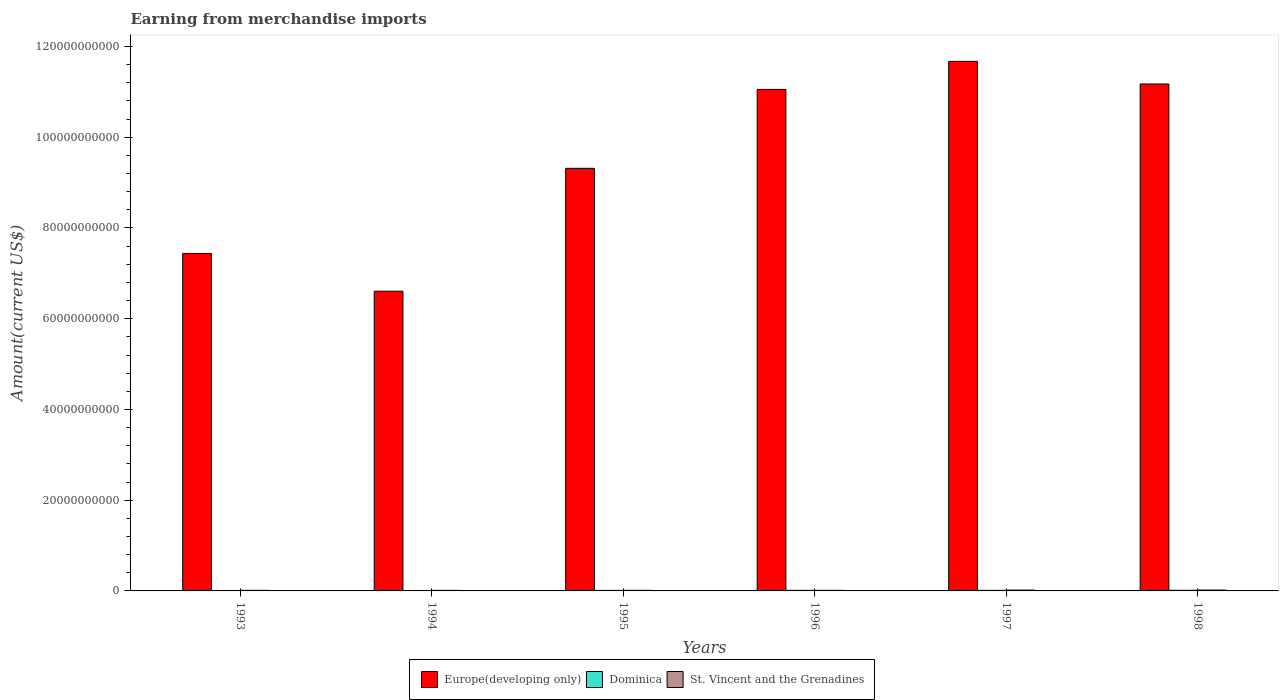Are the number of bars on each tick of the X-axis equal?
Keep it short and to the point. Yes. How many bars are there on the 6th tick from the left?
Ensure brevity in your answer.  3. How many bars are there on the 5th tick from the right?
Your answer should be compact. 3. What is the amount earned from merchandise imports in Dominica in 1996?
Offer a terse response. 1.29e+08. Across all years, what is the maximum amount earned from merchandise imports in St. Vincent and the Grenadines?
Ensure brevity in your answer.  1.93e+08. Across all years, what is the minimum amount earned from merchandise imports in St. Vincent and the Grenadines?
Your answer should be compact. 1.30e+08. What is the total amount earned from merchandise imports in Dominica in the graph?
Your answer should be very brief. 6.96e+08. What is the difference between the amount earned from merchandise imports in Europe(developing only) in 1996 and that in 1998?
Your answer should be compact. -1.19e+09. What is the difference between the amount earned from merchandise imports in Dominica in 1993 and the amount earned from merchandise imports in St. Vincent and the Grenadines in 1998?
Make the answer very short. -9.90e+07. What is the average amount earned from merchandise imports in Dominica per year?
Provide a short and direct response. 1.16e+08. In the year 1994, what is the difference between the amount earned from merchandise imports in Europe(developing only) and amount earned from merchandise imports in St. Vincent and the Grenadines?
Offer a very short reply. 6.59e+1. What is the ratio of the amount earned from merchandise imports in Europe(developing only) in 1994 to that in 1996?
Make the answer very short. 0.6. Is the amount earned from merchandise imports in Dominica in 1995 less than that in 1998?
Your response must be concise. Yes. What is the difference between the highest and the lowest amount earned from merchandise imports in Dominica?
Offer a very short reply. 4.20e+07. In how many years, is the amount earned from merchandise imports in Europe(developing only) greater than the average amount earned from merchandise imports in Europe(developing only) taken over all years?
Give a very brief answer. 3. What does the 1st bar from the left in 1998 represents?
Provide a succinct answer. Europe(developing only). What does the 2nd bar from the right in 1997 represents?
Keep it short and to the point. Dominica. How many bars are there?
Give a very brief answer. 18. What is the difference between two consecutive major ticks on the Y-axis?
Make the answer very short. 2.00e+1. Are the values on the major ticks of Y-axis written in scientific E-notation?
Keep it short and to the point. No. Does the graph contain any zero values?
Ensure brevity in your answer.  No. How many legend labels are there?
Provide a succinct answer. 3. How are the legend labels stacked?
Your response must be concise. Horizontal. What is the title of the graph?
Give a very brief answer. Earning from merchandise imports. What is the label or title of the Y-axis?
Your answer should be very brief. Amount(current US$). What is the Amount(current US$) of Europe(developing only) in 1993?
Provide a short and direct response. 7.44e+1. What is the Amount(current US$) in Dominica in 1993?
Your answer should be compact. 9.40e+07. What is the Amount(current US$) in St. Vincent and the Grenadines in 1993?
Offer a very short reply. 1.34e+08. What is the Amount(current US$) of Europe(developing only) in 1994?
Provide a succinct answer. 6.61e+1. What is the Amount(current US$) of Dominica in 1994?
Your answer should be compact. 9.60e+07. What is the Amount(current US$) of St. Vincent and the Grenadines in 1994?
Offer a very short reply. 1.30e+08. What is the Amount(current US$) in Europe(developing only) in 1995?
Ensure brevity in your answer.  9.31e+1. What is the Amount(current US$) of Dominica in 1995?
Make the answer very short. 1.17e+08. What is the Amount(current US$) of St. Vincent and the Grenadines in 1995?
Your response must be concise. 1.35e+08. What is the Amount(current US$) of Europe(developing only) in 1996?
Make the answer very short. 1.11e+11. What is the Amount(current US$) of Dominica in 1996?
Give a very brief answer. 1.29e+08. What is the Amount(current US$) of St. Vincent and the Grenadines in 1996?
Your answer should be very brief. 1.31e+08. What is the Amount(current US$) in Europe(developing only) in 1997?
Make the answer very short. 1.17e+11. What is the Amount(current US$) of Dominica in 1997?
Your answer should be very brief. 1.24e+08. What is the Amount(current US$) in St. Vincent and the Grenadines in 1997?
Ensure brevity in your answer.  1.88e+08. What is the Amount(current US$) in Europe(developing only) in 1998?
Give a very brief answer. 1.12e+11. What is the Amount(current US$) of Dominica in 1998?
Make the answer very short. 1.36e+08. What is the Amount(current US$) in St. Vincent and the Grenadines in 1998?
Provide a short and direct response. 1.93e+08. Across all years, what is the maximum Amount(current US$) of Europe(developing only)?
Offer a very short reply. 1.17e+11. Across all years, what is the maximum Amount(current US$) of Dominica?
Offer a very short reply. 1.36e+08. Across all years, what is the maximum Amount(current US$) of St. Vincent and the Grenadines?
Provide a short and direct response. 1.93e+08. Across all years, what is the minimum Amount(current US$) of Europe(developing only)?
Offer a very short reply. 6.61e+1. Across all years, what is the minimum Amount(current US$) in Dominica?
Make the answer very short. 9.40e+07. Across all years, what is the minimum Amount(current US$) of St. Vincent and the Grenadines?
Ensure brevity in your answer.  1.30e+08. What is the total Amount(current US$) in Europe(developing only) in the graph?
Your answer should be compact. 5.73e+11. What is the total Amount(current US$) in Dominica in the graph?
Offer a very short reply. 6.96e+08. What is the total Amount(current US$) in St. Vincent and the Grenadines in the graph?
Provide a short and direct response. 9.11e+08. What is the difference between the Amount(current US$) of Europe(developing only) in 1993 and that in 1994?
Make the answer very short. 8.33e+09. What is the difference between the Amount(current US$) in Dominica in 1993 and that in 1994?
Keep it short and to the point. -2.00e+06. What is the difference between the Amount(current US$) of St. Vincent and the Grenadines in 1993 and that in 1994?
Offer a very short reply. 4.00e+06. What is the difference between the Amount(current US$) in Europe(developing only) in 1993 and that in 1995?
Your answer should be compact. -1.88e+1. What is the difference between the Amount(current US$) in Dominica in 1993 and that in 1995?
Give a very brief answer. -2.30e+07. What is the difference between the Amount(current US$) in St. Vincent and the Grenadines in 1993 and that in 1995?
Offer a very short reply. -1.00e+06. What is the difference between the Amount(current US$) of Europe(developing only) in 1993 and that in 1996?
Keep it short and to the point. -3.62e+1. What is the difference between the Amount(current US$) of Dominica in 1993 and that in 1996?
Your response must be concise. -3.50e+07. What is the difference between the Amount(current US$) of Europe(developing only) in 1993 and that in 1997?
Give a very brief answer. -4.23e+1. What is the difference between the Amount(current US$) in Dominica in 1993 and that in 1997?
Provide a succinct answer. -3.00e+07. What is the difference between the Amount(current US$) of St. Vincent and the Grenadines in 1993 and that in 1997?
Your answer should be very brief. -5.40e+07. What is the difference between the Amount(current US$) in Europe(developing only) in 1993 and that in 1998?
Keep it short and to the point. -3.74e+1. What is the difference between the Amount(current US$) of Dominica in 1993 and that in 1998?
Provide a succinct answer. -4.20e+07. What is the difference between the Amount(current US$) in St. Vincent and the Grenadines in 1993 and that in 1998?
Give a very brief answer. -5.90e+07. What is the difference between the Amount(current US$) of Europe(developing only) in 1994 and that in 1995?
Make the answer very short. -2.71e+1. What is the difference between the Amount(current US$) in Dominica in 1994 and that in 1995?
Offer a terse response. -2.10e+07. What is the difference between the Amount(current US$) of St. Vincent and the Grenadines in 1994 and that in 1995?
Provide a short and direct response. -5.00e+06. What is the difference between the Amount(current US$) of Europe(developing only) in 1994 and that in 1996?
Offer a terse response. -4.45e+1. What is the difference between the Amount(current US$) in Dominica in 1994 and that in 1996?
Offer a terse response. -3.30e+07. What is the difference between the Amount(current US$) of St. Vincent and the Grenadines in 1994 and that in 1996?
Provide a succinct answer. -1.00e+06. What is the difference between the Amount(current US$) in Europe(developing only) in 1994 and that in 1997?
Your response must be concise. -5.07e+1. What is the difference between the Amount(current US$) in Dominica in 1994 and that in 1997?
Offer a very short reply. -2.80e+07. What is the difference between the Amount(current US$) in St. Vincent and the Grenadines in 1994 and that in 1997?
Offer a very short reply. -5.80e+07. What is the difference between the Amount(current US$) in Europe(developing only) in 1994 and that in 1998?
Give a very brief answer. -4.57e+1. What is the difference between the Amount(current US$) of Dominica in 1994 and that in 1998?
Make the answer very short. -4.00e+07. What is the difference between the Amount(current US$) in St. Vincent and the Grenadines in 1994 and that in 1998?
Your answer should be compact. -6.30e+07. What is the difference between the Amount(current US$) of Europe(developing only) in 1995 and that in 1996?
Your answer should be compact. -1.74e+1. What is the difference between the Amount(current US$) of Dominica in 1995 and that in 1996?
Your answer should be compact. -1.20e+07. What is the difference between the Amount(current US$) of Europe(developing only) in 1995 and that in 1997?
Provide a succinct answer. -2.36e+1. What is the difference between the Amount(current US$) of Dominica in 1995 and that in 1997?
Your answer should be very brief. -7.00e+06. What is the difference between the Amount(current US$) of St. Vincent and the Grenadines in 1995 and that in 1997?
Your response must be concise. -5.30e+07. What is the difference between the Amount(current US$) in Europe(developing only) in 1995 and that in 1998?
Offer a very short reply. -1.86e+1. What is the difference between the Amount(current US$) of Dominica in 1995 and that in 1998?
Your response must be concise. -1.90e+07. What is the difference between the Amount(current US$) of St. Vincent and the Grenadines in 1995 and that in 1998?
Offer a very short reply. -5.80e+07. What is the difference between the Amount(current US$) of Europe(developing only) in 1996 and that in 1997?
Ensure brevity in your answer.  -6.19e+09. What is the difference between the Amount(current US$) of St. Vincent and the Grenadines in 1996 and that in 1997?
Your answer should be compact. -5.70e+07. What is the difference between the Amount(current US$) in Europe(developing only) in 1996 and that in 1998?
Offer a very short reply. -1.19e+09. What is the difference between the Amount(current US$) of Dominica in 1996 and that in 1998?
Provide a short and direct response. -7.00e+06. What is the difference between the Amount(current US$) of St. Vincent and the Grenadines in 1996 and that in 1998?
Your response must be concise. -6.20e+07. What is the difference between the Amount(current US$) in Europe(developing only) in 1997 and that in 1998?
Provide a short and direct response. 4.99e+09. What is the difference between the Amount(current US$) in Dominica in 1997 and that in 1998?
Your answer should be very brief. -1.20e+07. What is the difference between the Amount(current US$) in St. Vincent and the Grenadines in 1997 and that in 1998?
Give a very brief answer. -5.00e+06. What is the difference between the Amount(current US$) of Europe(developing only) in 1993 and the Amount(current US$) of Dominica in 1994?
Ensure brevity in your answer.  7.43e+1. What is the difference between the Amount(current US$) in Europe(developing only) in 1993 and the Amount(current US$) in St. Vincent and the Grenadines in 1994?
Your answer should be very brief. 7.43e+1. What is the difference between the Amount(current US$) of Dominica in 1993 and the Amount(current US$) of St. Vincent and the Grenadines in 1994?
Keep it short and to the point. -3.60e+07. What is the difference between the Amount(current US$) of Europe(developing only) in 1993 and the Amount(current US$) of Dominica in 1995?
Offer a very short reply. 7.43e+1. What is the difference between the Amount(current US$) in Europe(developing only) in 1993 and the Amount(current US$) in St. Vincent and the Grenadines in 1995?
Offer a terse response. 7.42e+1. What is the difference between the Amount(current US$) in Dominica in 1993 and the Amount(current US$) in St. Vincent and the Grenadines in 1995?
Keep it short and to the point. -4.10e+07. What is the difference between the Amount(current US$) of Europe(developing only) in 1993 and the Amount(current US$) of Dominica in 1996?
Offer a very short reply. 7.43e+1. What is the difference between the Amount(current US$) of Europe(developing only) in 1993 and the Amount(current US$) of St. Vincent and the Grenadines in 1996?
Make the answer very short. 7.43e+1. What is the difference between the Amount(current US$) of Dominica in 1993 and the Amount(current US$) of St. Vincent and the Grenadines in 1996?
Provide a succinct answer. -3.70e+07. What is the difference between the Amount(current US$) of Europe(developing only) in 1993 and the Amount(current US$) of Dominica in 1997?
Provide a short and direct response. 7.43e+1. What is the difference between the Amount(current US$) in Europe(developing only) in 1993 and the Amount(current US$) in St. Vincent and the Grenadines in 1997?
Provide a succinct answer. 7.42e+1. What is the difference between the Amount(current US$) of Dominica in 1993 and the Amount(current US$) of St. Vincent and the Grenadines in 1997?
Make the answer very short. -9.40e+07. What is the difference between the Amount(current US$) in Europe(developing only) in 1993 and the Amount(current US$) in Dominica in 1998?
Give a very brief answer. 7.42e+1. What is the difference between the Amount(current US$) in Europe(developing only) in 1993 and the Amount(current US$) in St. Vincent and the Grenadines in 1998?
Your answer should be compact. 7.42e+1. What is the difference between the Amount(current US$) in Dominica in 1993 and the Amount(current US$) in St. Vincent and the Grenadines in 1998?
Provide a succinct answer. -9.90e+07. What is the difference between the Amount(current US$) of Europe(developing only) in 1994 and the Amount(current US$) of Dominica in 1995?
Your answer should be very brief. 6.59e+1. What is the difference between the Amount(current US$) in Europe(developing only) in 1994 and the Amount(current US$) in St. Vincent and the Grenadines in 1995?
Offer a terse response. 6.59e+1. What is the difference between the Amount(current US$) in Dominica in 1994 and the Amount(current US$) in St. Vincent and the Grenadines in 1995?
Offer a very short reply. -3.90e+07. What is the difference between the Amount(current US$) in Europe(developing only) in 1994 and the Amount(current US$) in Dominica in 1996?
Give a very brief answer. 6.59e+1. What is the difference between the Amount(current US$) of Europe(developing only) in 1994 and the Amount(current US$) of St. Vincent and the Grenadines in 1996?
Offer a terse response. 6.59e+1. What is the difference between the Amount(current US$) of Dominica in 1994 and the Amount(current US$) of St. Vincent and the Grenadines in 1996?
Keep it short and to the point. -3.50e+07. What is the difference between the Amount(current US$) of Europe(developing only) in 1994 and the Amount(current US$) of Dominica in 1997?
Give a very brief answer. 6.59e+1. What is the difference between the Amount(current US$) in Europe(developing only) in 1994 and the Amount(current US$) in St. Vincent and the Grenadines in 1997?
Your answer should be compact. 6.59e+1. What is the difference between the Amount(current US$) in Dominica in 1994 and the Amount(current US$) in St. Vincent and the Grenadines in 1997?
Your answer should be very brief. -9.20e+07. What is the difference between the Amount(current US$) of Europe(developing only) in 1994 and the Amount(current US$) of Dominica in 1998?
Keep it short and to the point. 6.59e+1. What is the difference between the Amount(current US$) of Europe(developing only) in 1994 and the Amount(current US$) of St. Vincent and the Grenadines in 1998?
Your answer should be compact. 6.59e+1. What is the difference between the Amount(current US$) of Dominica in 1994 and the Amount(current US$) of St. Vincent and the Grenadines in 1998?
Ensure brevity in your answer.  -9.70e+07. What is the difference between the Amount(current US$) in Europe(developing only) in 1995 and the Amount(current US$) in Dominica in 1996?
Offer a very short reply. 9.30e+1. What is the difference between the Amount(current US$) in Europe(developing only) in 1995 and the Amount(current US$) in St. Vincent and the Grenadines in 1996?
Ensure brevity in your answer.  9.30e+1. What is the difference between the Amount(current US$) of Dominica in 1995 and the Amount(current US$) of St. Vincent and the Grenadines in 1996?
Provide a succinct answer. -1.40e+07. What is the difference between the Amount(current US$) in Europe(developing only) in 1995 and the Amount(current US$) in Dominica in 1997?
Make the answer very short. 9.30e+1. What is the difference between the Amount(current US$) in Europe(developing only) in 1995 and the Amount(current US$) in St. Vincent and the Grenadines in 1997?
Make the answer very short. 9.30e+1. What is the difference between the Amount(current US$) of Dominica in 1995 and the Amount(current US$) of St. Vincent and the Grenadines in 1997?
Make the answer very short. -7.10e+07. What is the difference between the Amount(current US$) in Europe(developing only) in 1995 and the Amount(current US$) in Dominica in 1998?
Your response must be concise. 9.30e+1. What is the difference between the Amount(current US$) in Europe(developing only) in 1995 and the Amount(current US$) in St. Vincent and the Grenadines in 1998?
Your answer should be very brief. 9.30e+1. What is the difference between the Amount(current US$) of Dominica in 1995 and the Amount(current US$) of St. Vincent and the Grenadines in 1998?
Your answer should be compact. -7.60e+07. What is the difference between the Amount(current US$) in Europe(developing only) in 1996 and the Amount(current US$) in Dominica in 1997?
Provide a short and direct response. 1.10e+11. What is the difference between the Amount(current US$) of Europe(developing only) in 1996 and the Amount(current US$) of St. Vincent and the Grenadines in 1997?
Your response must be concise. 1.10e+11. What is the difference between the Amount(current US$) in Dominica in 1996 and the Amount(current US$) in St. Vincent and the Grenadines in 1997?
Offer a terse response. -5.90e+07. What is the difference between the Amount(current US$) in Europe(developing only) in 1996 and the Amount(current US$) in Dominica in 1998?
Your response must be concise. 1.10e+11. What is the difference between the Amount(current US$) of Europe(developing only) in 1996 and the Amount(current US$) of St. Vincent and the Grenadines in 1998?
Offer a terse response. 1.10e+11. What is the difference between the Amount(current US$) in Dominica in 1996 and the Amount(current US$) in St. Vincent and the Grenadines in 1998?
Your response must be concise. -6.40e+07. What is the difference between the Amount(current US$) in Europe(developing only) in 1997 and the Amount(current US$) in Dominica in 1998?
Keep it short and to the point. 1.17e+11. What is the difference between the Amount(current US$) of Europe(developing only) in 1997 and the Amount(current US$) of St. Vincent and the Grenadines in 1998?
Your answer should be very brief. 1.17e+11. What is the difference between the Amount(current US$) in Dominica in 1997 and the Amount(current US$) in St. Vincent and the Grenadines in 1998?
Your answer should be compact. -6.90e+07. What is the average Amount(current US$) in Europe(developing only) per year?
Your answer should be very brief. 9.54e+1. What is the average Amount(current US$) in Dominica per year?
Your answer should be very brief. 1.16e+08. What is the average Amount(current US$) in St. Vincent and the Grenadines per year?
Your answer should be compact. 1.52e+08. In the year 1993, what is the difference between the Amount(current US$) of Europe(developing only) and Amount(current US$) of Dominica?
Give a very brief answer. 7.43e+1. In the year 1993, what is the difference between the Amount(current US$) of Europe(developing only) and Amount(current US$) of St. Vincent and the Grenadines?
Offer a terse response. 7.42e+1. In the year 1993, what is the difference between the Amount(current US$) of Dominica and Amount(current US$) of St. Vincent and the Grenadines?
Provide a succinct answer. -4.00e+07. In the year 1994, what is the difference between the Amount(current US$) of Europe(developing only) and Amount(current US$) of Dominica?
Offer a terse response. 6.60e+1. In the year 1994, what is the difference between the Amount(current US$) in Europe(developing only) and Amount(current US$) in St. Vincent and the Grenadines?
Make the answer very short. 6.59e+1. In the year 1994, what is the difference between the Amount(current US$) in Dominica and Amount(current US$) in St. Vincent and the Grenadines?
Keep it short and to the point. -3.40e+07. In the year 1995, what is the difference between the Amount(current US$) in Europe(developing only) and Amount(current US$) in Dominica?
Make the answer very short. 9.30e+1. In the year 1995, what is the difference between the Amount(current US$) of Europe(developing only) and Amount(current US$) of St. Vincent and the Grenadines?
Ensure brevity in your answer.  9.30e+1. In the year 1995, what is the difference between the Amount(current US$) of Dominica and Amount(current US$) of St. Vincent and the Grenadines?
Keep it short and to the point. -1.80e+07. In the year 1996, what is the difference between the Amount(current US$) in Europe(developing only) and Amount(current US$) in Dominica?
Make the answer very short. 1.10e+11. In the year 1996, what is the difference between the Amount(current US$) in Europe(developing only) and Amount(current US$) in St. Vincent and the Grenadines?
Give a very brief answer. 1.10e+11. In the year 1996, what is the difference between the Amount(current US$) in Dominica and Amount(current US$) in St. Vincent and the Grenadines?
Ensure brevity in your answer.  -2.00e+06. In the year 1997, what is the difference between the Amount(current US$) in Europe(developing only) and Amount(current US$) in Dominica?
Give a very brief answer. 1.17e+11. In the year 1997, what is the difference between the Amount(current US$) in Europe(developing only) and Amount(current US$) in St. Vincent and the Grenadines?
Keep it short and to the point. 1.17e+11. In the year 1997, what is the difference between the Amount(current US$) of Dominica and Amount(current US$) of St. Vincent and the Grenadines?
Ensure brevity in your answer.  -6.40e+07. In the year 1998, what is the difference between the Amount(current US$) of Europe(developing only) and Amount(current US$) of Dominica?
Ensure brevity in your answer.  1.12e+11. In the year 1998, what is the difference between the Amount(current US$) in Europe(developing only) and Amount(current US$) in St. Vincent and the Grenadines?
Give a very brief answer. 1.12e+11. In the year 1998, what is the difference between the Amount(current US$) in Dominica and Amount(current US$) in St. Vincent and the Grenadines?
Give a very brief answer. -5.70e+07. What is the ratio of the Amount(current US$) in Europe(developing only) in 1993 to that in 1994?
Provide a short and direct response. 1.13. What is the ratio of the Amount(current US$) in Dominica in 1993 to that in 1994?
Provide a short and direct response. 0.98. What is the ratio of the Amount(current US$) of St. Vincent and the Grenadines in 1993 to that in 1994?
Your response must be concise. 1.03. What is the ratio of the Amount(current US$) in Europe(developing only) in 1993 to that in 1995?
Ensure brevity in your answer.  0.8. What is the ratio of the Amount(current US$) of Dominica in 1993 to that in 1995?
Offer a very short reply. 0.8. What is the ratio of the Amount(current US$) of Europe(developing only) in 1993 to that in 1996?
Make the answer very short. 0.67. What is the ratio of the Amount(current US$) in Dominica in 1993 to that in 1996?
Offer a very short reply. 0.73. What is the ratio of the Amount(current US$) of St. Vincent and the Grenadines in 1993 to that in 1996?
Keep it short and to the point. 1.02. What is the ratio of the Amount(current US$) in Europe(developing only) in 1993 to that in 1997?
Offer a very short reply. 0.64. What is the ratio of the Amount(current US$) in Dominica in 1993 to that in 1997?
Make the answer very short. 0.76. What is the ratio of the Amount(current US$) in St. Vincent and the Grenadines in 1993 to that in 1997?
Offer a very short reply. 0.71. What is the ratio of the Amount(current US$) of Europe(developing only) in 1993 to that in 1998?
Your response must be concise. 0.67. What is the ratio of the Amount(current US$) in Dominica in 1993 to that in 1998?
Provide a succinct answer. 0.69. What is the ratio of the Amount(current US$) of St. Vincent and the Grenadines in 1993 to that in 1998?
Your answer should be compact. 0.69. What is the ratio of the Amount(current US$) of Europe(developing only) in 1994 to that in 1995?
Offer a very short reply. 0.71. What is the ratio of the Amount(current US$) in Dominica in 1994 to that in 1995?
Ensure brevity in your answer.  0.82. What is the ratio of the Amount(current US$) of Europe(developing only) in 1994 to that in 1996?
Offer a very short reply. 0.6. What is the ratio of the Amount(current US$) of Dominica in 1994 to that in 1996?
Give a very brief answer. 0.74. What is the ratio of the Amount(current US$) in St. Vincent and the Grenadines in 1994 to that in 1996?
Keep it short and to the point. 0.99. What is the ratio of the Amount(current US$) of Europe(developing only) in 1994 to that in 1997?
Your answer should be very brief. 0.57. What is the ratio of the Amount(current US$) in Dominica in 1994 to that in 1997?
Make the answer very short. 0.77. What is the ratio of the Amount(current US$) of St. Vincent and the Grenadines in 1994 to that in 1997?
Your answer should be very brief. 0.69. What is the ratio of the Amount(current US$) in Europe(developing only) in 1994 to that in 1998?
Make the answer very short. 0.59. What is the ratio of the Amount(current US$) of Dominica in 1994 to that in 1998?
Ensure brevity in your answer.  0.71. What is the ratio of the Amount(current US$) in St. Vincent and the Grenadines in 1994 to that in 1998?
Make the answer very short. 0.67. What is the ratio of the Amount(current US$) in Europe(developing only) in 1995 to that in 1996?
Your response must be concise. 0.84. What is the ratio of the Amount(current US$) in Dominica in 1995 to that in 1996?
Give a very brief answer. 0.91. What is the ratio of the Amount(current US$) of St. Vincent and the Grenadines in 1995 to that in 1996?
Provide a short and direct response. 1.03. What is the ratio of the Amount(current US$) of Europe(developing only) in 1995 to that in 1997?
Offer a terse response. 0.8. What is the ratio of the Amount(current US$) in Dominica in 1995 to that in 1997?
Give a very brief answer. 0.94. What is the ratio of the Amount(current US$) of St. Vincent and the Grenadines in 1995 to that in 1997?
Your response must be concise. 0.72. What is the ratio of the Amount(current US$) in Europe(developing only) in 1995 to that in 1998?
Ensure brevity in your answer.  0.83. What is the ratio of the Amount(current US$) of Dominica in 1995 to that in 1998?
Ensure brevity in your answer.  0.86. What is the ratio of the Amount(current US$) in St. Vincent and the Grenadines in 1995 to that in 1998?
Your answer should be compact. 0.7. What is the ratio of the Amount(current US$) of Europe(developing only) in 1996 to that in 1997?
Offer a terse response. 0.95. What is the ratio of the Amount(current US$) in Dominica in 1996 to that in 1997?
Your answer should be compact. 1.04. What is the ratio of the Amount(current US$) of St. Vincent and the Grenadines in 1996 to that in 1997?
Make the answer very short. 0.7. What is the ratio of the Amount(current US$) in Europe(developing only) in 1996 to that in 1998?
Keep it short and to the point. 0.99. What is the ratio of the Amount(current US$) in Dominica in 1996 to that in 1998?
Provide a short and direct response. 0.95. What is the ratio of the Amount(current US$) of St. Vincent and the Grenadines in 1996 to that in 1998?
Keep it short and to the point. 0.68. What is the ratio of the Amount(current US$) of Europe(developing only) in 1997 to that in 1998?
Provide a short and direct response. 1.04. What is the ratio of the Amount(current US$) of Dominica in 1997 to that in 1998?
Keep it short and to the point. 0.91. What is the ratio of the Amount(current US$) of St. Vincent and the Grenadines in 1997 to that in 1998?
Your response must be concise. 0.97. What is the difference between the highest and the second highest Amount(current US$) in Europe(developing only)?
Your answer should be very brief. 4.99e+09. What is the difference between the highest and the second highest Amount(current US$) of Dominica?
Give a very brief answer. 7.00e+06. What is the difference between the highest and the second highest Amount(current US$) of St. Vincent and the Grenadines?
Your response must be concise. 5.00e+06. What is the difference between the highest and the lowest Amount(current US$) of Europe(developing only)?
Offer a very short reply. 5.07e+1. What is the difference between the highest and the lowest Amount(current US$) of Dominica?
Your answer should be very brief. 4.20e+07. What is the difference between the highest and the lowest Amount(current US$) of St. Vincent and the Grenadines?
Ensure brevity in your answer.  6.30e+07. 